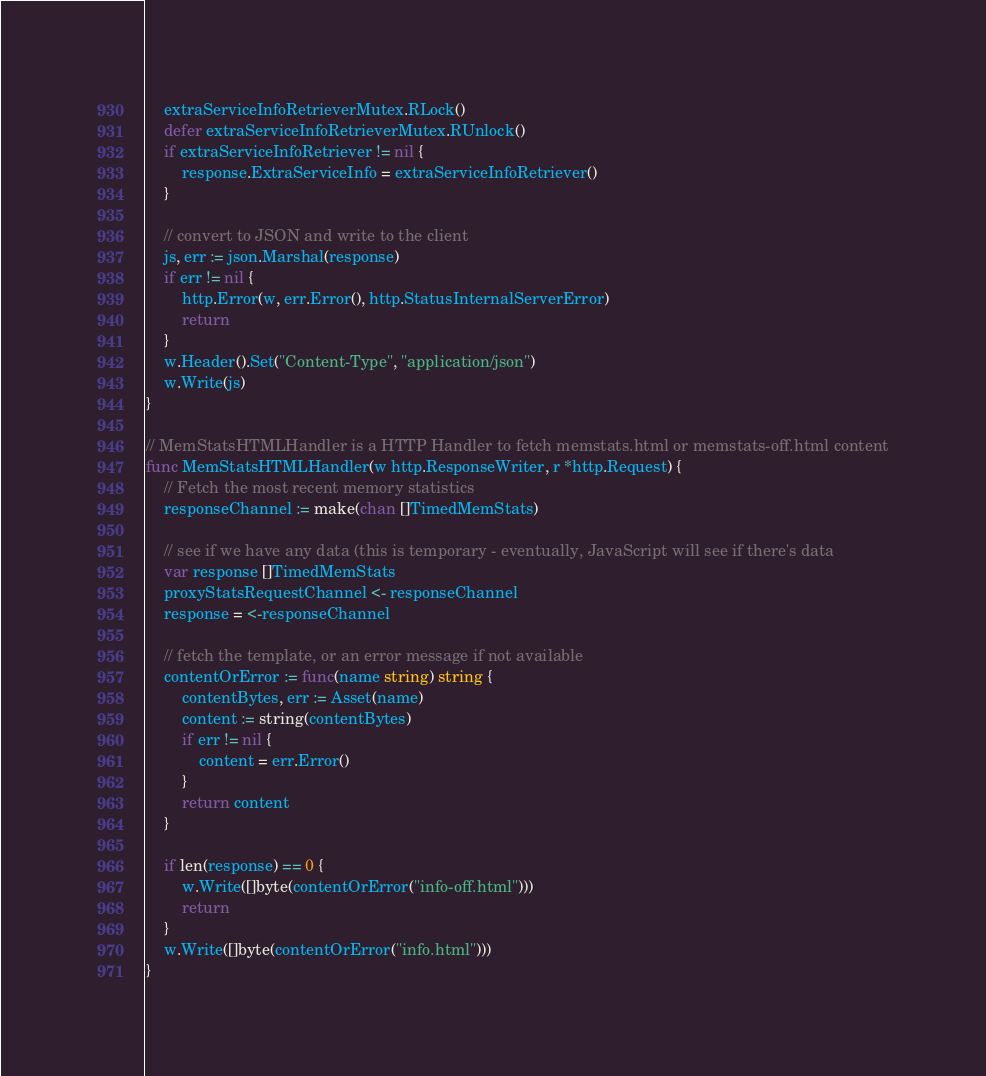<code> <loc_0><loc_0><loc_500><loc_500><_Go_>	extraServiceInfoRetrieverMutex.RLock()
	defer extraServiceInfoRetrieverMutex.RUnlock()
	if extraServiceInfoRetriever != nil {
		response.ExtraServiceInfo = extraServiceInfoRetriever()
	}

	// convert to JSON and write to the client
	js, err := json.Marshal(response)
	if err != nil {
		http.Error(w, err.Error(), http.StatusInternalServerError)
		return
	}
	w.Header().Set("Content-Type", "application/json")
	w.Write(js)
}

// MemStatsHTMLHandler is a HTTP Handler to fetch memstats.html or memstats-off.html content
func MemStatsHTMLHandler(w http.ResponseWriter, r *http.Request) {
	// Fetch the most recent memory statistics
	responseChannel := make(chan []TimedMemStats)

	// see if we have any data (this is temporary - eventually, JavaScript will see if there's data
	var response []TimedMemStats
	proxyStatsRequestChannel <- responseChannel
	response = <-responseChannel

	// fetch the template, or an error message if not available
	contentOrError := func(name string) string {
		contentBytes, err := Asset(name)
		content := string(contentBytes)
		if err != nil {
			content = err.Error()
		}
		return content
	}

	if len(response) == 0 {
		w.Write([]byte(contentOrError("info-off.html")))
		return
	}
	w.Write([]byte(contentOrError("info.html")))
}
</code> 